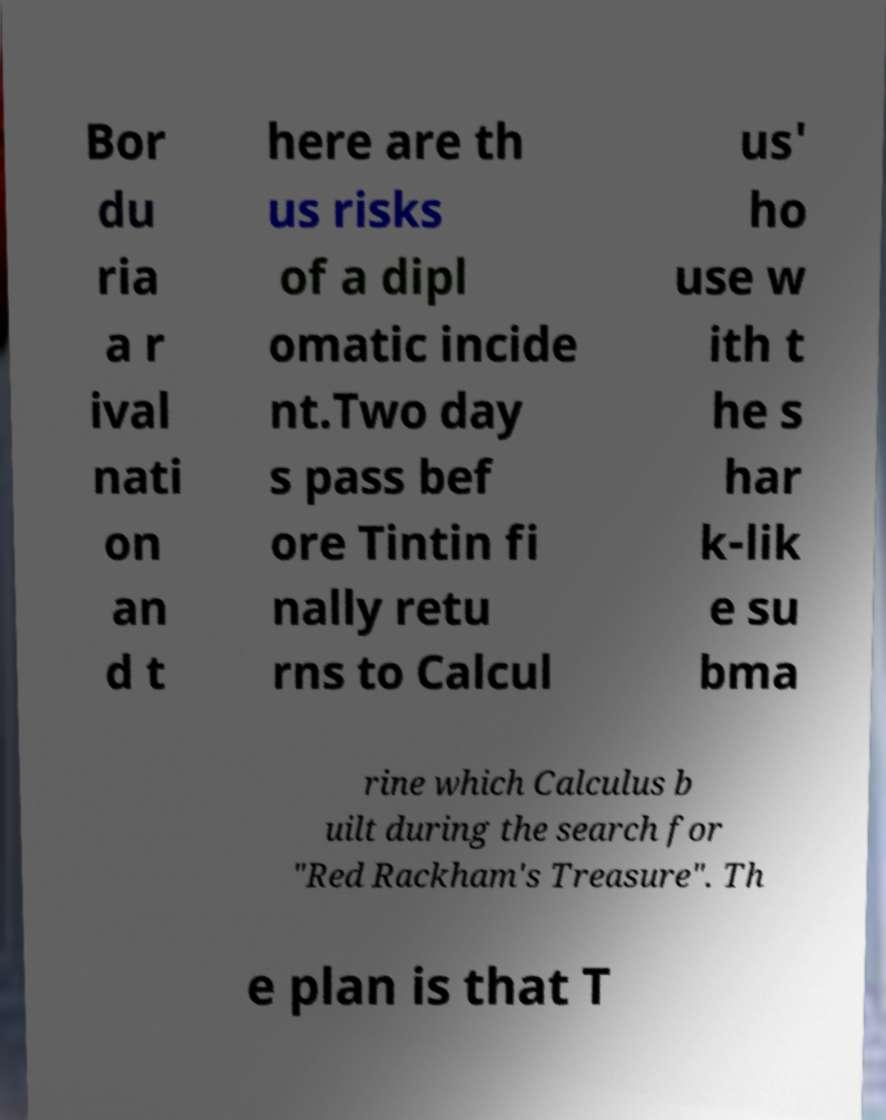Could you assist in decoding the text presented in this image and type it out clearly? Bor du ria a r ival nati on an d t here are th us risks of a dipl omatic incide nt.Two day s pass bef ore Tintin fi nally retu rns to Calcul us' ho use w ith t he s har k-lik e su bma rine which Calculus b uilt during the search for "Red Rackham's Treasure". Th e plan is that T 